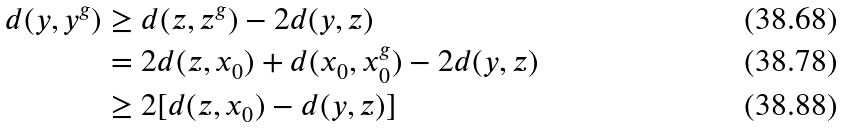Convert formula to latex. <formula><loc_0><loc_0><loc_500><loc_500>d ( y , y ^ { g } ) & \geq d ( z , z ^ { g } ) - 2 d ( y , z ) \\ & = 2 d ( z , x _ { 0 } ) + d ( x _ { 0 } , x _ { 0 } ^ { g } ) - 2 d ( y , z ) \\ & \geq 2 [ d ( z , x _ { 0 } ) - d ( y , z ) ]</formula> 